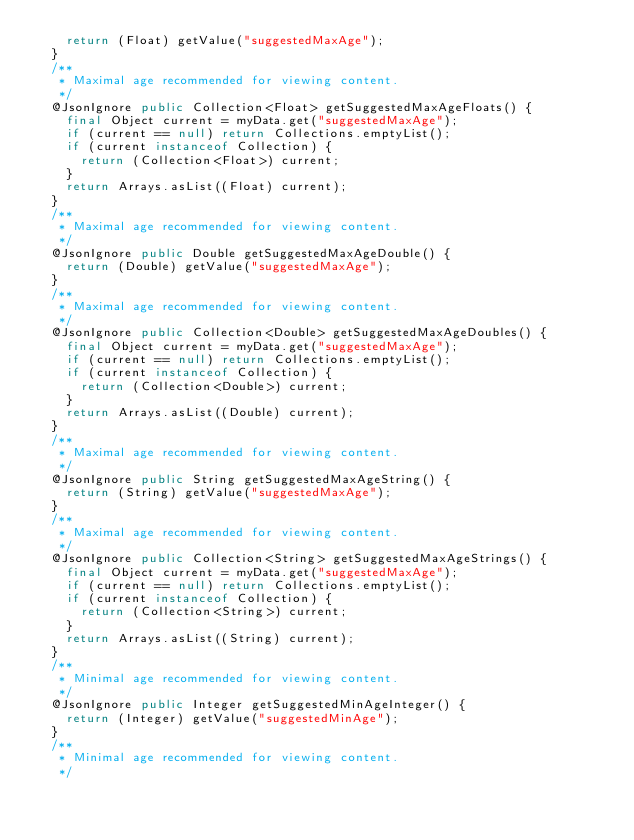Convert code to text. <code><loc_0><loc_0><loc_500><loc_500><_Java_>    return (Float) getValue("suggestedMaxAge");
  }
  /**
   * Maximal age recommended for viewing content.
   */
  @JsonIgnore public Collection<Float> getSuggestedMaxAgeFloats() {
    final Object current = myData.get("suggestedMaxAge");
    if (current == null) return Collections.emptyList();
    if (current instanceof Collection) {
      return (Collection<Float>) current;
    }
    return Arrays.asList((Float) current);
  }
  /**
   * Maximal age recommended for viewing content.
   */
  @JsonIgnore public Double getSuggestedMaxAgeDouble() {
    return (Double) getValue("suggestedMaxAge");
  }
  /**
   * Maximal age recommended for viewing content.
   */
  @JsonIgnore public Collection<Double> getSuggestedMaxAgeDoubles() {
    final Object current = myData.get("suggestedMaxAge");
    if (current == null) return Collections.emptyList();
    if (current instanceof Collection) {
      return (Collection<Double>) current;
    }
    return Arrays.asList((Double) current);
  }
  /**
   * Maximal age recommended for viewing content.
   */
  @JsonIgnore public String getSuggestedMaxAgeString() {
    return (String) getValue("suggestedMaxAge");
  }
  /**
   * Maximal age recommended for viewing content.
   */
  @JsonIgnore public Collection<String> getSuggestedMaxAgeStrings() {
    final Object current = myData.get("suggestedMaxAge");
    if (current == null) return Collections.emptyList();
    if (current instanceof Collection) {
      return (Collection<String>) current;
    }
    return Arrays.asList((String) current);
  }
  /**
   * Minimal age recommended for viewing content.
   */
  @JsonIgnore public Integer getSuggestedMinAgeInteger() {
    return (Integer) getValue("suggestedMinAge");
  }
  /**
   * Minimal age recommended for viewing content.
   */</code> 